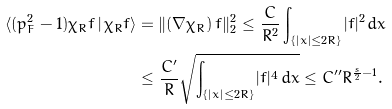Convert formula to latex. <formula><loc_0><loc_0><loc_500><loc_500>\langle ( p _ { F } ^ { 2 } - 1 ) \chi _ { R } f \, | \, \chi _ { R } f \rangle & = \| ( \nabla \chi _ { R } ) \, f \| _ { 2 } ^ { 2 } \leq \frac { C } { R ^ { 2 } } \int _ { \{ | x | \leq 2 R \} } | f | ^ { 2 } \, d x \\ & \leq \frac { C ^ { \prime } } { R } \sqrt { \int _ { \{ | x | \leq 2 R \} } | f | ^ { 4 } \, d x } \leq C ^ { \prime \prime } R ^ { \frac { s } { 2 } - 1 } .</formula> 